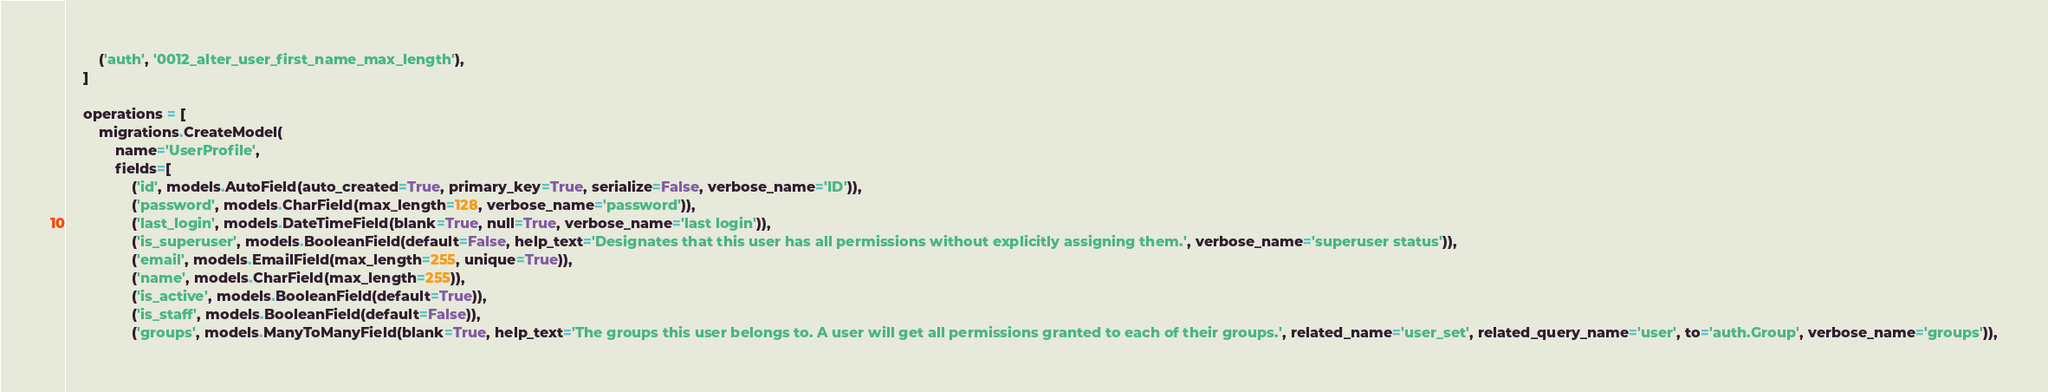<code> <loc_0><loc_0><loc_500><loc_500><_Python_>        ('auth', '0012_alter_user_first_name_max_length'),
    ]

    operations = [
        migrations.CreateModel(
            name='UserProfile',
            fields=[
                ('id', models.AutoField(auto_created=True, primary_key=True, serialize=False, verbose_name='ID')),
                ('password', models.CharField(max_length=128, verbose_name='password')),
                ('last_login', models.DateTimeField(blank=True, null=True, verbose_name='last login')),
                ('is_superuser', models.BooleanField(default=False, help_text='Designates that this user has all permissions without explicitly assigning them.', verbose_name='superuser status')),
                ('email', models.EmailField(max_length=255, unique=True)),
                ('name', models.CharField(max_length=255)),
                ('is_active', models.BooleanField(default=True)),
                ('is_staff', models.BooleanField(default=False)),
                ('groups', models.ManyToManyField(blank=True, help_text='The groups this user belongs to. A user will get all permissions granted to each of their groups.', related_name='user_set', related_query_name='user', to='auth.Group', verbose_name='groups')),</code> 